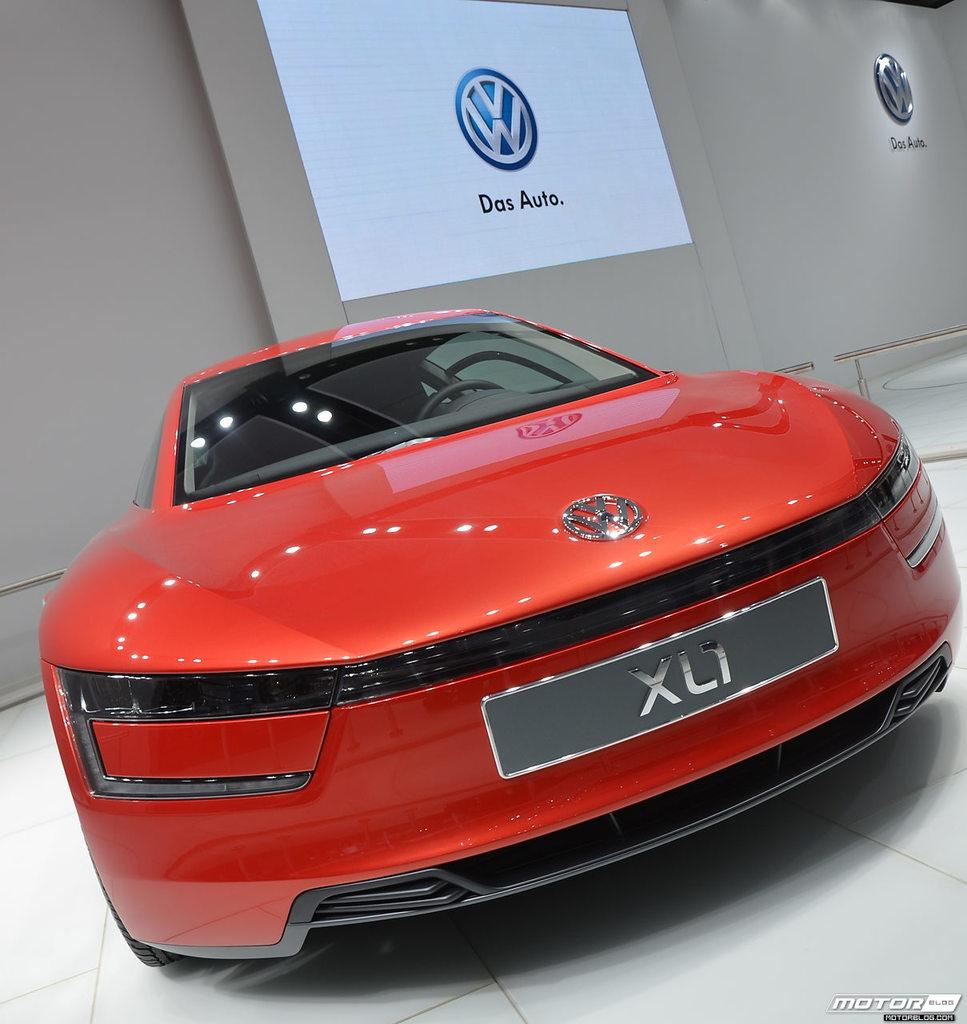What type of vehicle is in the foreground of the image? There is a red color car in the foreground of the image. Where is the car located in relation to the image? The car is on the floor. What can be seen in the background of the image? There is a wall, a logo, and a screen in the background of the image. What type of breakfast is being served on the car in the image? There is no breakfast present in the image; it features a red color car on the floor with a background containing a wall, a logo, and a screen. 